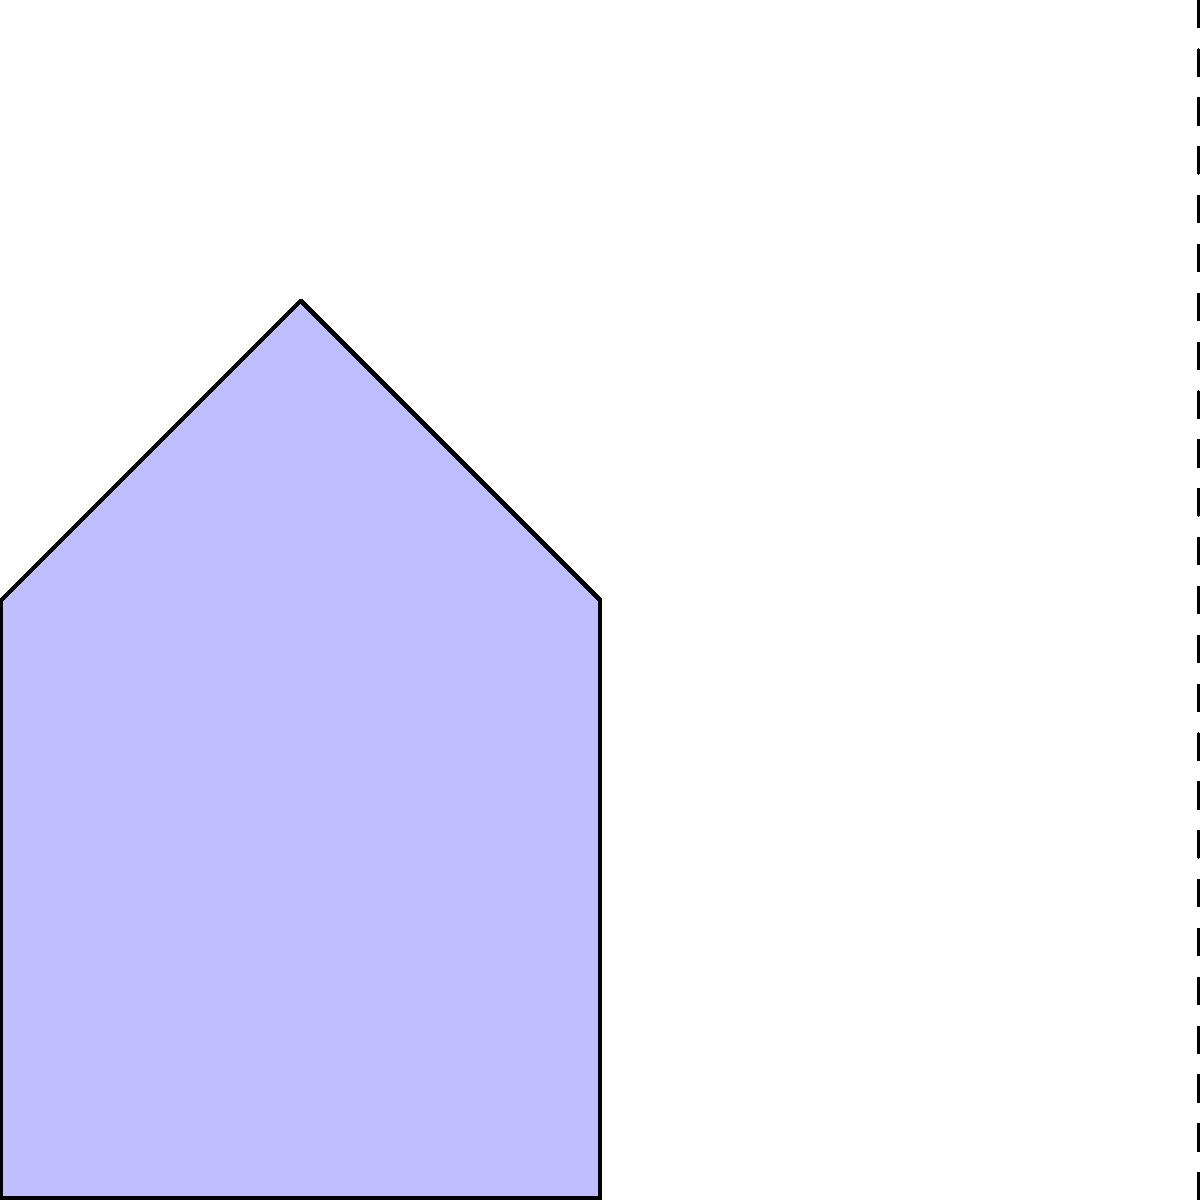In the image above, a blue asymmetrical shape is shown on the left side of a vertical mirror line. Which of the following best describes the correct mirror image on the right side?

A) The shape is exactly the same as the original
B) The shape is flipped horizontally
C) The shape is rotated 180 degrees
D) The shape is inverted vertically To visualize the correct mirror image of an asymmetrical object, follow these steps:

1. Identify the mirror line: In this case, it's the vertical dashed line in the middle of the image.

2. Understand the principle of reflection: Each point of the object is reflected across the mirror line at an equal distance on the opposite side.

3. Analyze the original shape: The blue shape has a flat bottom, a vertical right side, and a sloped top with a peak slightly to the right of center.

4. Visualize the reflection:
   a) The flat bottom remains parallel to the mirror line.
   b) The vertical right side of the original becomes the vertical left side of the reflection.
   c) The sloped top is flipped, with the peak now slightly to the left of center in the reflection.

5. Compare with the given options:
   A) Not correct, as the reflection is not identical to the original.
   B) Correct, as horizontal flipping is equivalent to reflection across a vertical line.
   C) Not correct, as rotation would change the orientation of all sides.
   D) Not correct, as vertical inversion would flip the shape upside down.

The correct mirror image is represented by the faded red shape on the right side of the mirror line, which matches the description in option B.
Answer: B 